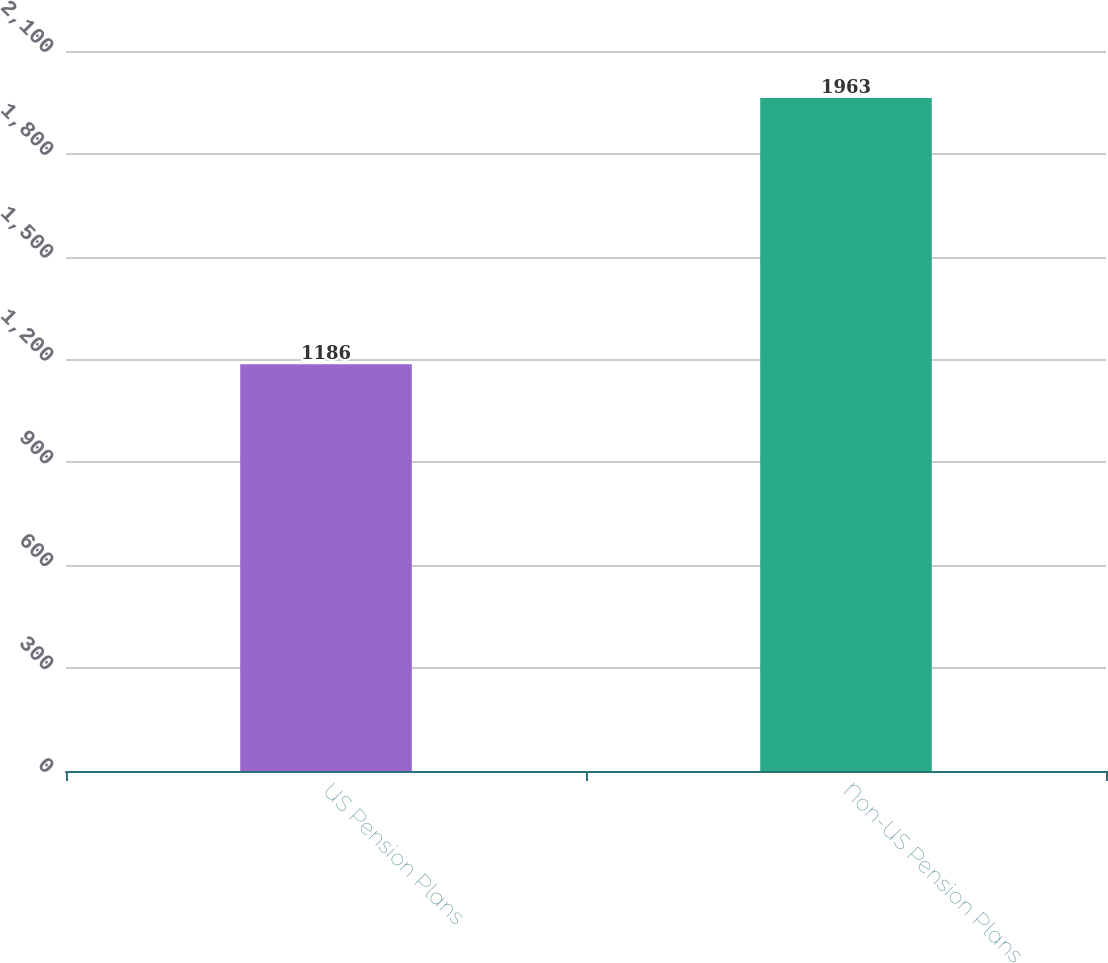Convert chart. <chart><loc_0><loc_0><loc_500><loc_500><bar_chart><fcel>US Pension Plans<fcel>Non-US Pension Plans<nl><fcel>1186<fcel>1963<nl></chart> 